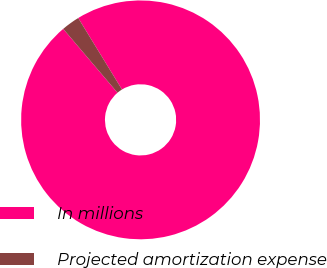<chart> <loc_0><loc_0><loc_500><loc_500><pie_chart><fcel>In millions<fcel>Projected amortization expense<nl><fcel>97.53%<fcel>2.47%<nl></chart> 